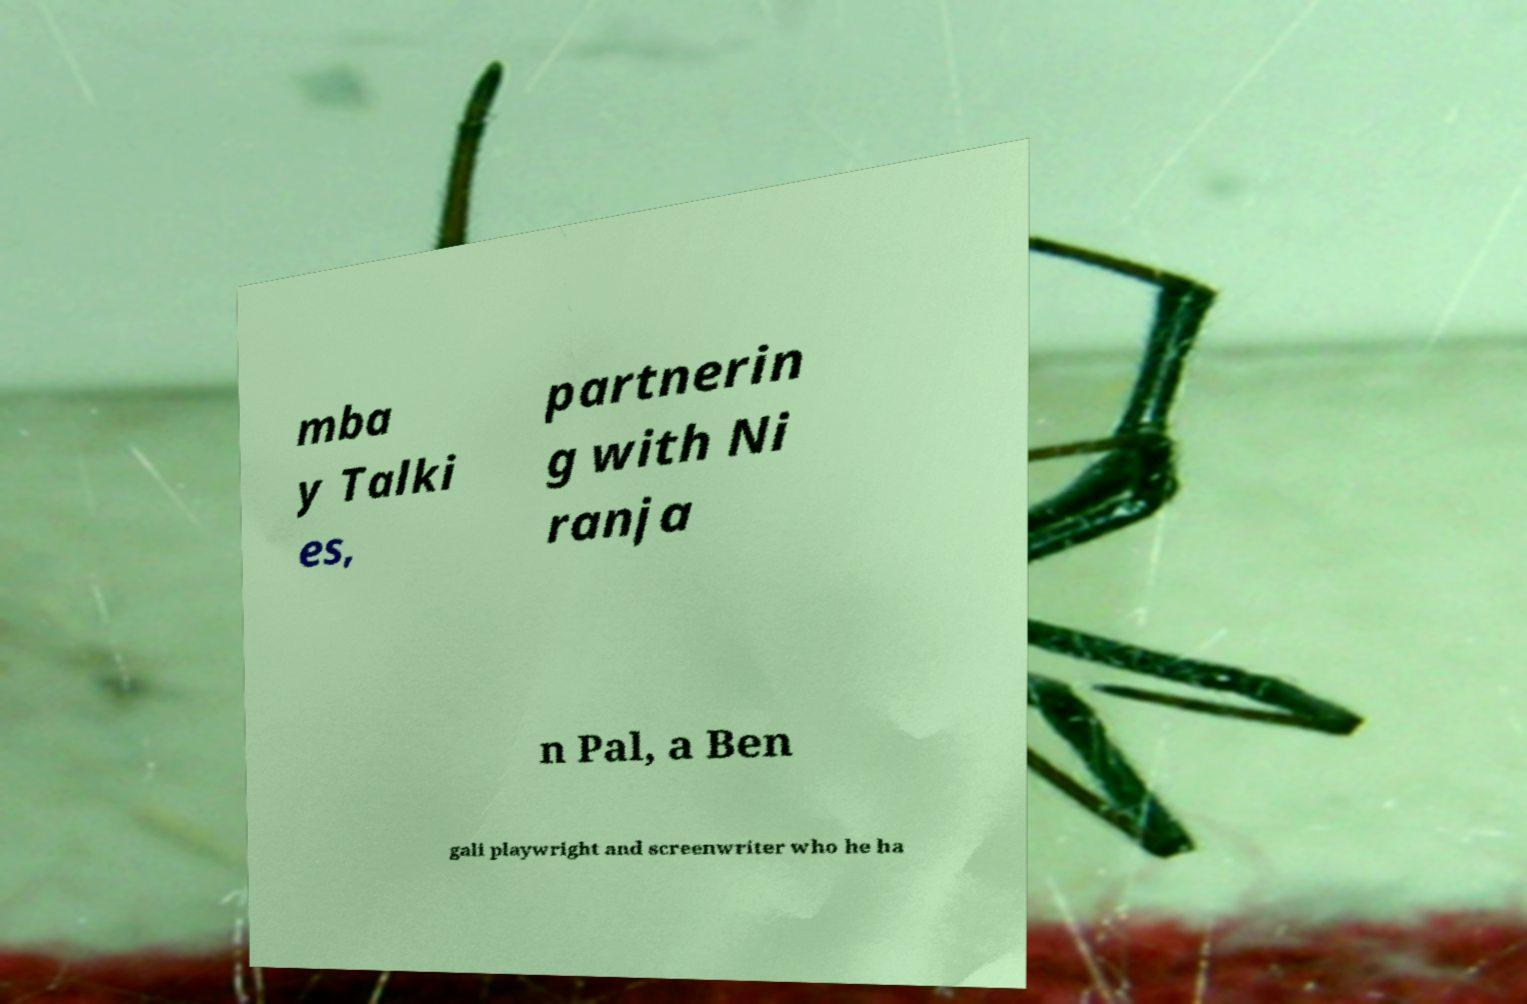Can you read and provide the text displayed in the image?This photo seems to have some interesting text. Can you extract and type it out for me? mba y Talki es, partnerin g with Ni ranja n Pal, a Ben gali playwright and screenwriter who he ha 